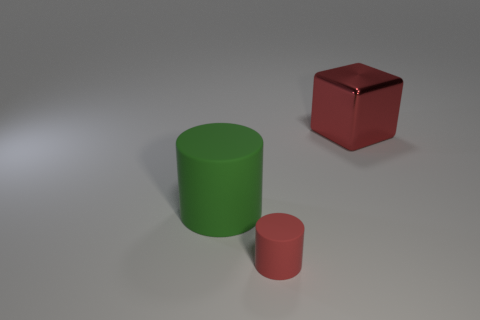There is another thing that is the same color as the small thing; what is its shape?
Your response must be concise. Cube. There is a large thing that is in front of the red block; what color is it?
Provide a short and direct response. Green. Is there a small purple metallic object of the same shape as the big green object?
Offer a very short reply. No. Is the number of red blocks that are in front of the big green rubber cylinder less than the number of large red shiny things right of the red cube?
Keep it short and to the point. No. The small thing has what color?
Provide a succinct answer. Red. Is there a large green cylinder in front of the large object that is in front of the red cube?
Your answer should be compact. No. What number of green matte objects have the same size as the red block?
Your answer should be compact. 1. How many red matte objects are behind the rubber cylinder behind the cylinder in front of the green matte cylinder?
Your answer should be compact. 0. What number of objects are both to the right of the green cylinder and to the left of the big block?
Offer a very short reply. 1. Is there anything else that has the same color as the big cylinder?
Provide a succinct answer. No. 